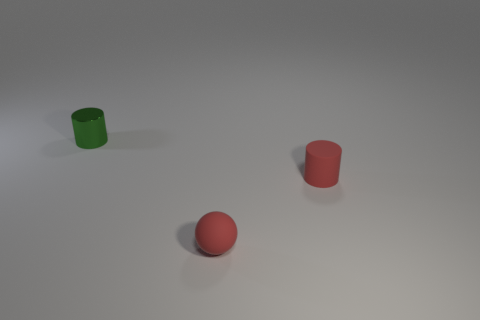If these objects were part of a game, what sort of game do you think they could be used for? If these objects were part of a game, they might be used for a simple sorting or target practice game. For instance, the goal could be to toss the ball into the cylinders, or the cylinders might have to be organized by size or color. Their basic shapes and colors make them versatile for a variety of educational and recreational activities. 